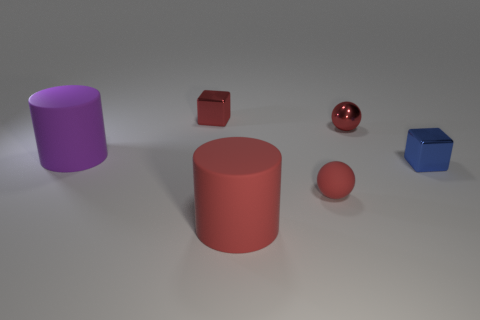Add 1 large rubber cylinders. How many objects exist? 7 Subtract all purple cylinders. How many cylinders are left? 1 Subtract 1 balls. How many balls are left? 1 Subtract all large purple objects. Subtract all matte spheres. How many objects are left? 4 Add 6 blocks. How many blocks are left? 8 Add 3 big metallic blocks. How many big metallic blocks exist? 3 Subtract 0 blue cylinders. How many objects are left? 6 Subtract all cylinders. How many objects are left? 4 